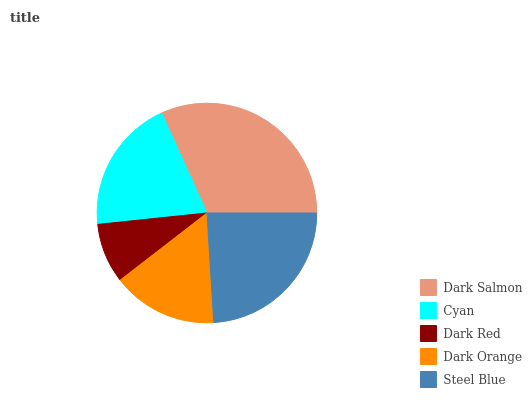Is Dark Red the minimum?
Answer yes or no. Yes. Is Dark Salmon the maximum?
Answer yes or no. Yes. Is Cyan the minimum?
Answer yes or no. No. Is Cyan the maximum?
Answer yes or no. No. Is Dark Salmon greater than Cyan?
Answer yes or no. Yes. Is Cyan less than Dark Salmon?
Answer yes or no. Yes. Is Cyan greater than Dark Salmon?
Answer yes or no. No. Is Dark Salmon less than Cyan?
Answer yes or no. No. Is Cyan the high median?
Answer yes or no. Yes. Is Cyan the low median?
Answer yes or no. Yes. Is Dark Orange the high median?
Answer yes or no. No. Is Dark Salmon the low median?
Answer yes or no. No. 